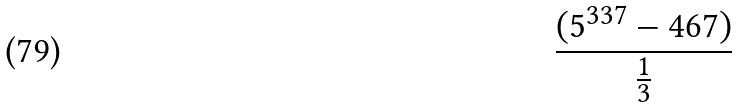Convert formula to latex. <formula><loc_0><loc_0><loc_500><loc_500>\frac { ( 5 ^ { 3 3 7 } - 4 6 7 ) } { \frac { 1 } { 3 } }</formula> 